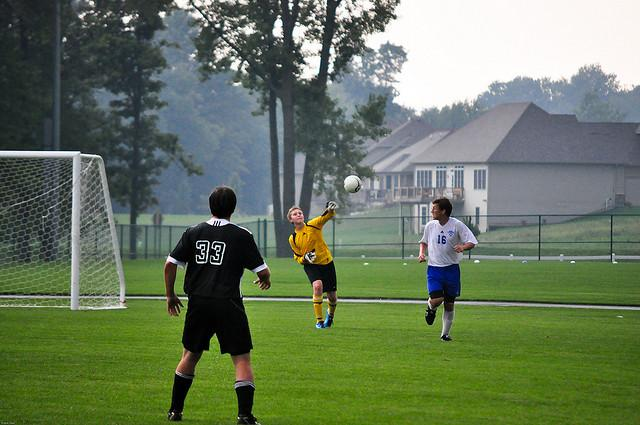Why is the one guy wearing a yellow uniform? goalie 